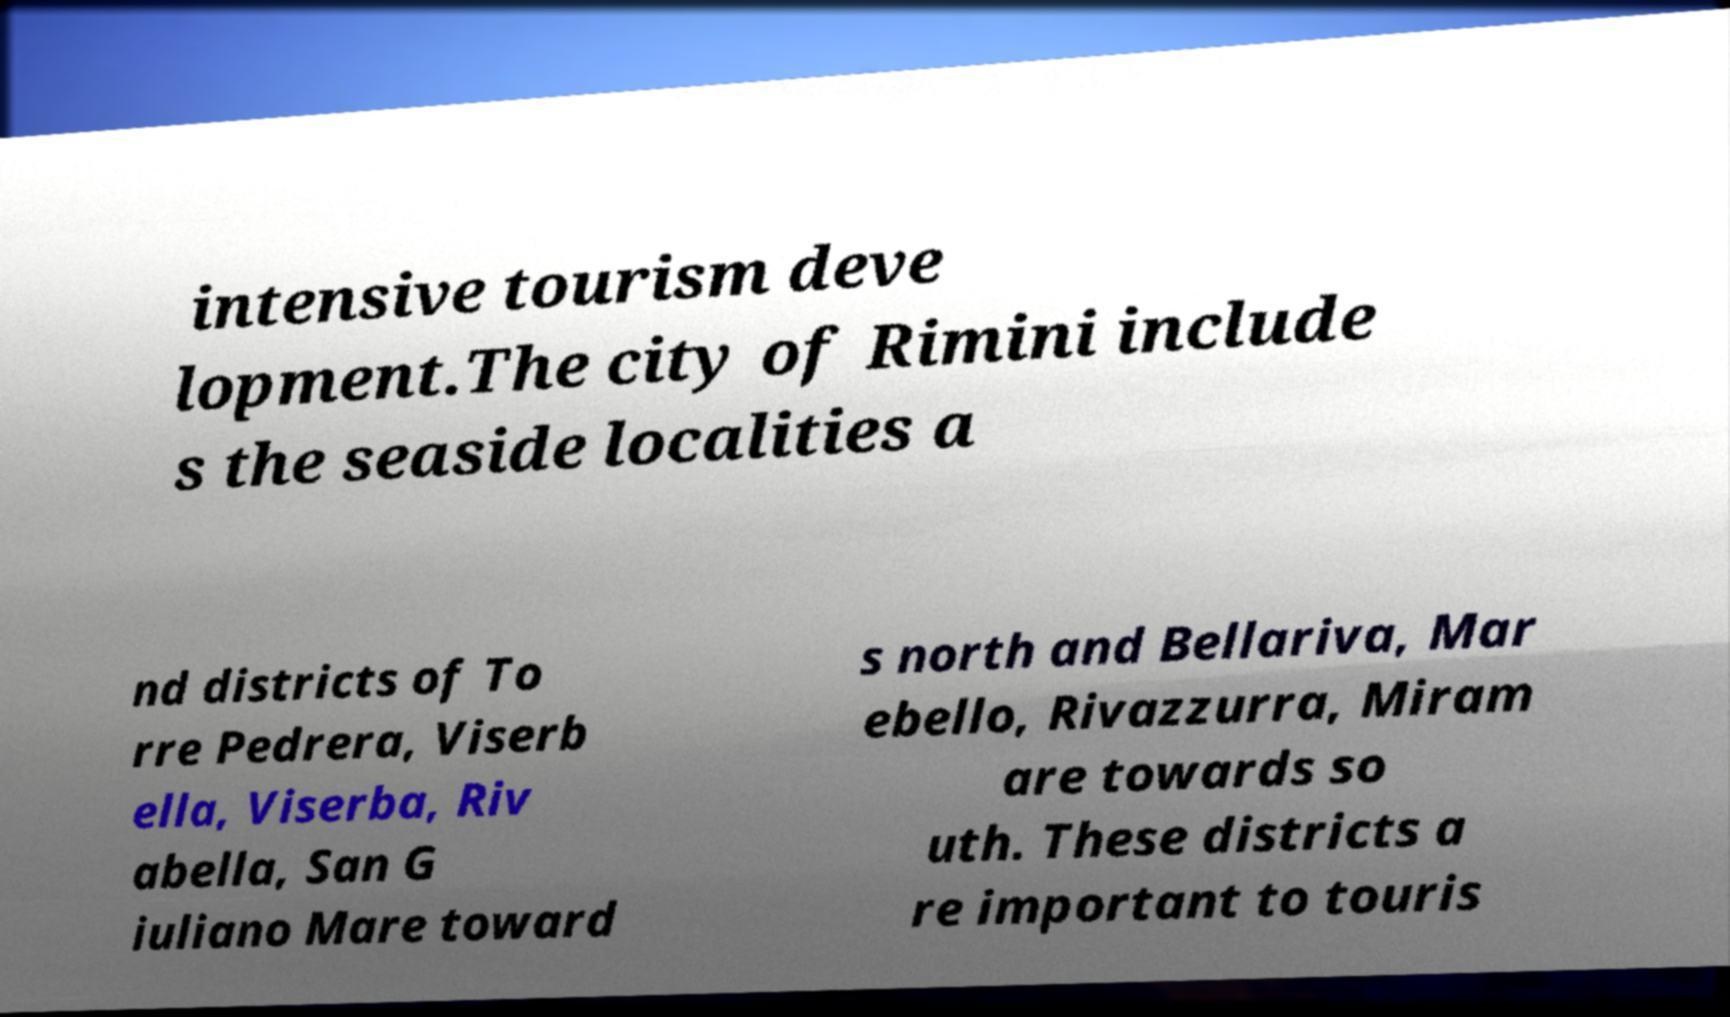Please identify and transcribe the text found in this image. intensive tourism deve lopment.The city of Rimini include s the seaside localities a nd districts of To rre Pedrera, Viserb ella, Viserba, Riv abella, San G iuliano Mare toward s north and Bellariva, Mar ebello, Rivazzurra, Miram are towards so uth. These districts a re important to touris 